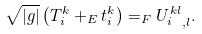Convert formula to latex. <formula><loc_0><loc_0><loc_500><loc_500>\sqrt { | g | } \left ( T _ { i } ^ { k } + _ { E } t _ { i } ^ { k } \right ) = _ { F } { U _ { i } ^ { k l } } _ { , l } .</formula> 